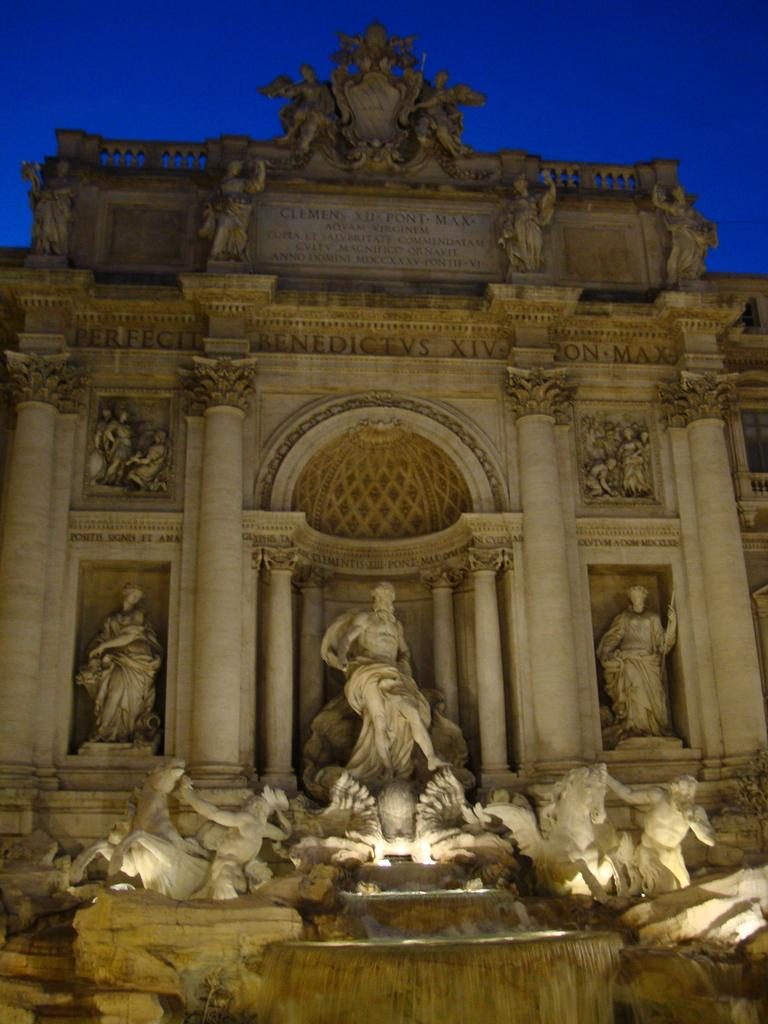What type of structure is visible in the image? There is a building in the image. What artistic elements can be seen in the image? There are sculptures and a fountain in the image. What is the purpose of the fountain in the image? The purpose of the fountain in the image is to provide a decorative water feature. What is written or depicted on the wall at the top of the building? There is text on the wall at the top of the building. Who is the creator of the passenger depicted in the image? There is no passenger depicted in the image; it features a building, sculptures, a fountain, and text on the wall. 